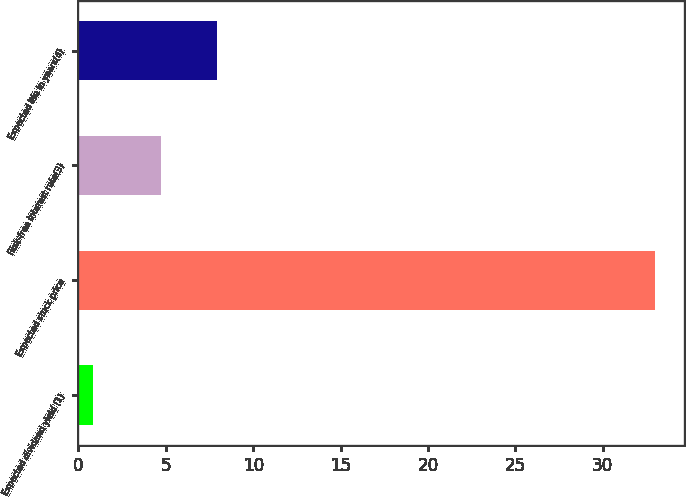<chart> <loc_0><loc_0><loc_500><loc_500><bar_chart><fcel>Expected dividend yield (1)<fcel>Expected stock price<fcel>Risk-free interest rate(3)<fcel>Expected life in years(4)<nl><fcel>0.85<fcel>33<fcel>4.7<fcel>7.92<nl></chart> 